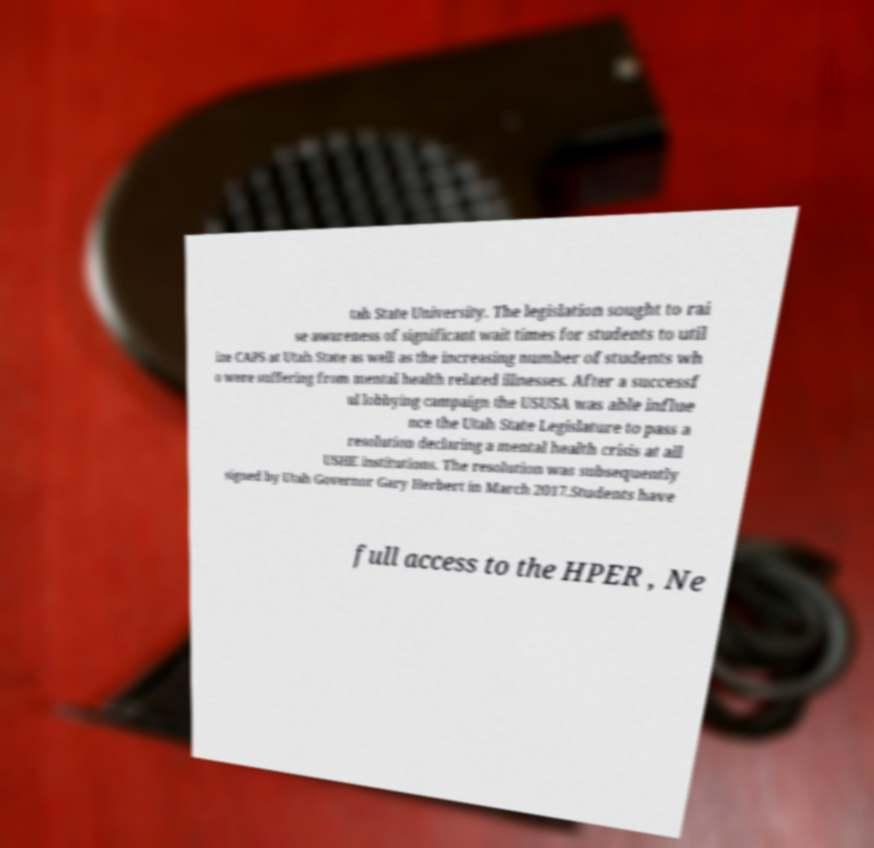There's text embedded in this image that I need extracted. Can you transcribe it verbatim? tah State University. The legislation sought to rai se awareness of significant wait times for students to util ize CAPS at Utah State as well as the increasing number of students wh o were suffering from mental health related illnesses. After a successf ul lobbying campaign the USUSA was able influe nce the Utah State Legislature to pass a resolution declaring a mental health crisis at all USHE institutions. The resolution was subsequently signed by Utah Governor Gary Herbert in March 2017.Students have full access to the HPER , Ne 